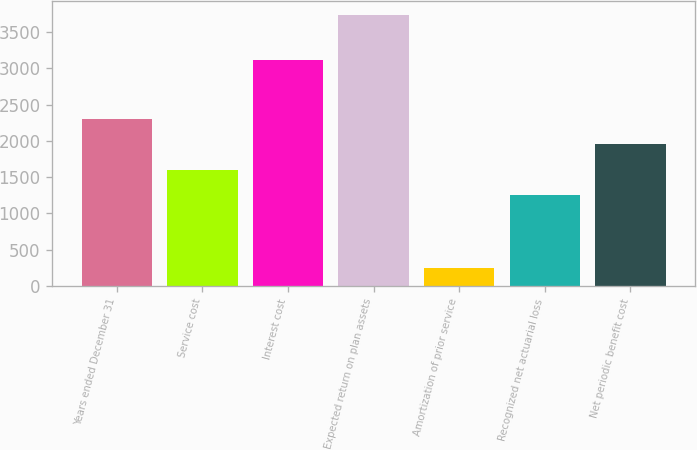<chart> <loc_0><loc_0><loc_500><loc_500><bar_chart><fcel>Years ended December 31<fcel>Service cost<fcel>Interest cost<fcel>Expected return on plan assets<fcel>Amortization of prior service<fcel>Recognized net actuarial loss<fcel>Net periodic benefit cost<nl><fcel>2303.1<fcel>1603.7<fcel>3116<fcel>3741<fcel>244<fcel>1254<fcel>1953.4<nl></chart> 